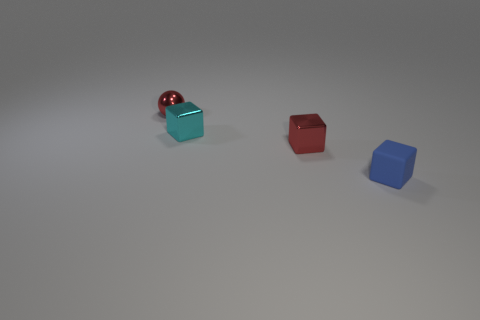What is the shape of the red thing left of the small red metal thing that is in front of the tiny cyan thing?
Make the answer very short. Sphere. What is the shape of the blue object that is the same size as the metallic ball?
Offer a very short reply. Cube. Are there any other cyan objects of the same shape as the small cyan metal thing?
Offer a very short reply. No. What is the material of the tiny cyan object?
Provide a succinct answer. Metal. There is a tiny metal sphere; are there any tiny red shiny things in front of it?
Make the answer very short. Yes. There is a object that is behind the small cyan shiny cube; what number of small red metal things are on the right side of it?
Offer a terse response. 1. What material is the red cube that is the same size as the blue matte thing?
Provide a succinct answer. Metal. How many other objects are the same material as the cyan block?
Ensure brevity in your answer.  2. There is a rubber thing; what number of small red blocks are behind it?
Your response must be concise. 1. What number of cylinders are cyan objects or red objects?
Keep it short and to the point. 0. 